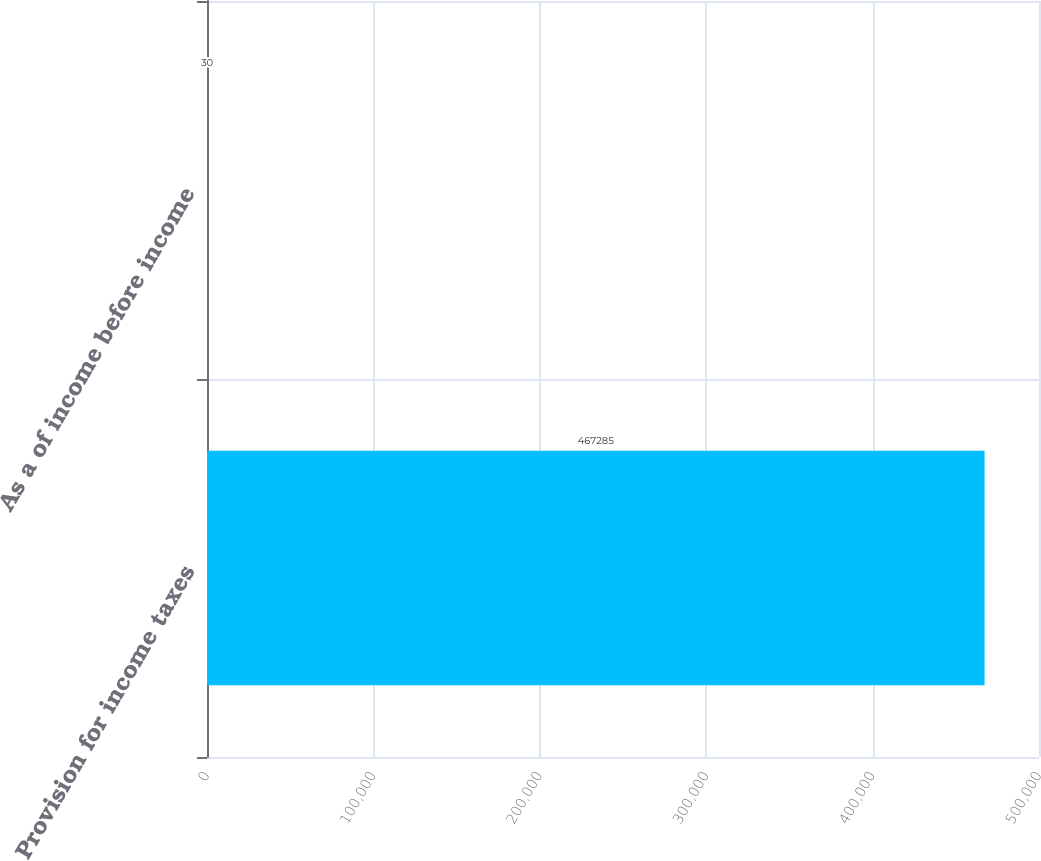Convert chart to OTSL. <chart><loc_0><loc_0><loc_500><loc_500><bar_chart><fcel>Provision for income taxes<fcel>As a of income before income<nl><fcel>467285<fcel>30<nl></chart> 